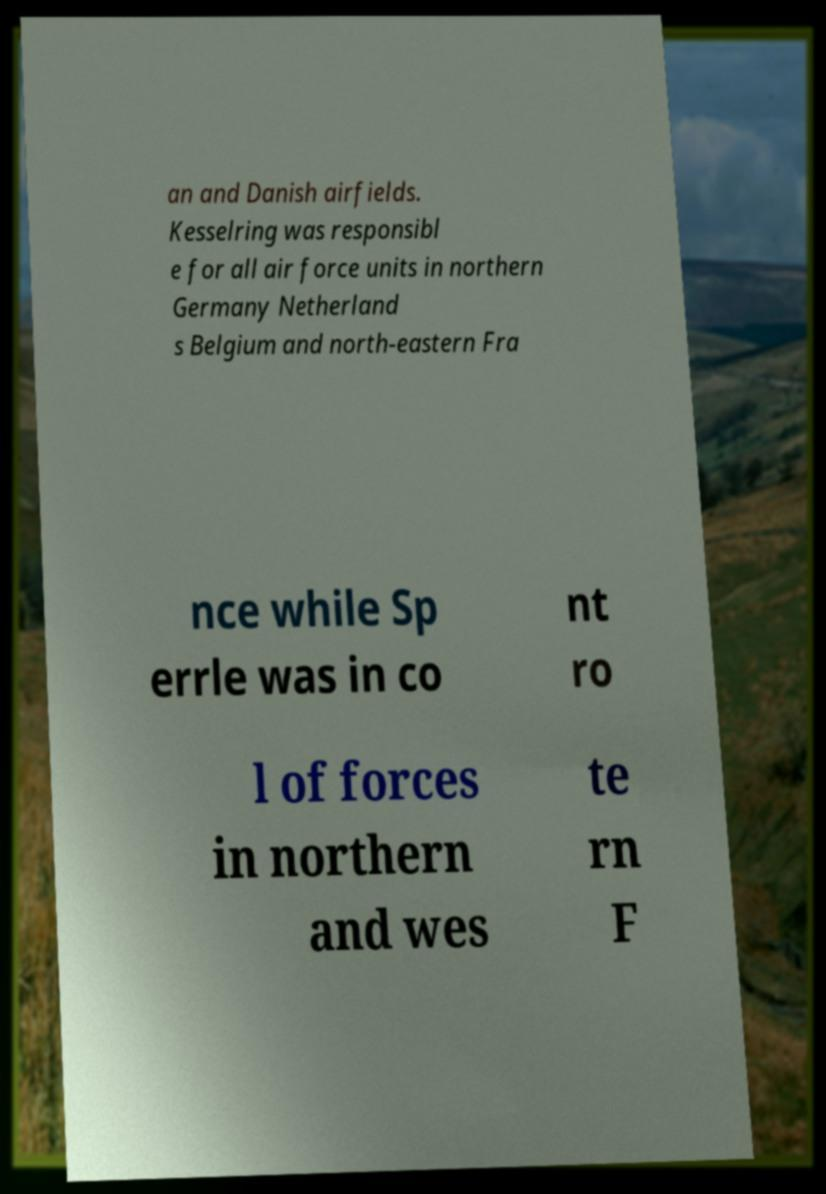I need the written content from this picture converted into text. Can you do that? an and Danish airfields. Kesselring was responsibl e for all air force units in northern Germany Netherland s Belgium and north-eastern Fra nce while Sp errle was in co nt ro l of forces in northern and wes te rn F 